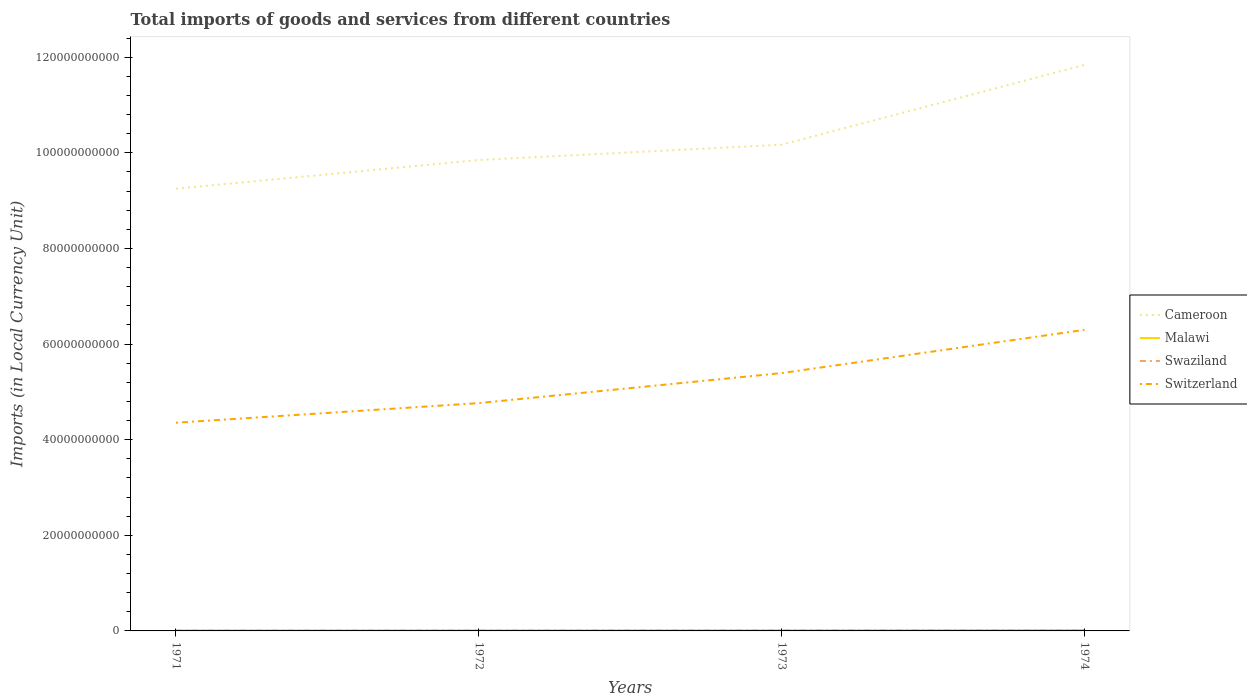Across all years, what is the maximum Amount of goods and services imports in Malawi?
Offer a very short reply. 1.08e+08. In which year was the Amount of goods and services imports in Malawi maximum?
Make the answer very short. 1971. What is the total Amount of goods and services imports in Malawi in the graph?
Keep it short and to the point. -4.30e+07. What is the difference between the highest and the second highest Amount of goods and services imports in Swaziland?
Make the answer very short. 5.28e+07. Is the Amount of goods and services imports in Swaziland strictly greater than the Amount of goods and services imports in Malawi over the years?
Offer a terse response. Yes. How many lines are there?
Offer a very short reply. 4. How many years are there in the graph?
Provide a succinct answer. 4. What is the difference between two consecutive major ticks on the Y-axis?
Offer a very short reply. 2.00e+1. Does the graph contain grids?
Provide a short and direct response. No. How many legend labels are there?
Keep it short and to the point. 4. What is the title of the graph?
Offer a terse response. Total imports of goods and services from different countries. What is the label or title of the Y-axis?
Your response must be concise. Imports (in Local Currency Unit). What is the Imports (in Local Currency Unit) in Cameroon in 1971?
Make the answer very short. 9.25e+1. What is the Imports (in Local Currency Unit) of Malawi in 1971?
Provide a short and direct response. 1.08e+08. What is the Imports (in Local Currency Unit) of Swaziland in 1971?
Provide a short and direct response. 5.36e+07. What is the Imports (in Local Currency Unit) of Switzerland in 1971?
Give a very brief answer. 4.35e+1. What is the Imports (in Local Currency Unit) in Cameroon in 1972?
Provide a short and direct response. 9.85e+1. What is the Imports (in Local Currency Unit) in Malawi in 1972?
Ensure brevity in your answer.  1.24e+08. What is the Imports (in Local Currency Unit) in Swaziland in 1972?
Make the answer very short. 6.61e+07. What is the Imports (in Local Currency Unit) of Switzerland in 1972?
Provide a succinct answer. 4.77e+1. What is the Imports (in Local Currency Unit) in Cameroon in 1973?
Ensure brevity in your answer.  1.02e+11. What is the Imports (in Local Currency Unit) of Malawi in 1973?
Your answer should be very brief. 1.37e+08. What is the Imports (in Local Currency Unit) in Swaziland in 1973?
Your answer should be very brief. 8.65e+07. What is the Imports (in Local Currency Unit) in Switzerland in 1973?
Offer a very short reply. 5.39e+1. What is the Imports (in Local Currency Unit) in Cameroon in 1974?
Offer a very short reply. 1.18e+11. What is the Imports (in Local Currency Unit) in Malawi in 1974?
Give a very brief answer. 1.80e+08. What is the Imports (in Local Currency Unit) of Swaziland in 1974?
Offer a very short reply. 1.06e+08. What is the Imports (in Local Currency Unit) of Switzerland in 1974?
Give a very brief answer. 6.30e+1. Across all years, what is the maximum Imports (in Local Currency Unit) of Cameroon?
Your answer should be very brief. 1.18e+11. Across all years, what is the maximum Imports (in Local Currency Unit) of Malawi?
Offer a terse response. 1.80e+08. Across all years, what is the maximum Imports (in Local Currency Unit) of Swaziland?
Your response must be concise. 1.06e+08. Across all years, what is the maximum Imports (in Local Currency Unit) in Switzerland?
Offer a terse response. 6.30e+1. Across all years, what is the minimum Imports (in Local Currency Unit) of Cameroon?
Make the answer very short. 9.25e+1. Across all years, what is the minimum Imports (in Local Currency Unit) in Malawi?
Make the answer very short. 1.08e+08. Across all years, what is the minimum Imports (in Local Currency Unit) of Swaziland?
Provide a short and direct response. 5.36e+07. Across all years, what is the minimum Imports (in Local Currency Unit) of Switzerland?
Your answer should be very brief. 4.35e+1. What is the total Imports (in Local Currency Unit) in Cameroon in the graph?
Your answer should be compact. 4.11e+11. What is the total Imports (in Local Currency Unit) in Malawi in the graph?
Keep it short and to the point. 5.48e+08. What is the total Imports (in Local Currency Unit) in Swaziland in the graph?
Your response must be concise. 3.13e+08. What is the total Imports (in Local Currency Unit) in Switzerland in the graph?
Your response must be concise. 2.08e+11. What is the difference between the Imports (in Local Currency Unit) in Cameroon in 1971 and that in 1972?
Offer a very short reply. -6.00e+09. What is the difference between the Imports (in Local Currency Unit) of Malawi in 1971 and that in 1972?
Provide a succinct answer. -1.58e+07. What is the difference between the Imports (in Local Currency Unit) in Swaziland in 1971 and that in 1972?
Provide a succinct answer. -1.25e+07. What is the difference between the Imports (in Local Currency Unit) of Switzerland in 1971 and that in 1972?
Your answer should be very brief. -4.10e+09. What is the difference between the Imports (in Local Currency Unit) of Cameroon in 1971 and that in 1973?
Offer a terse response. -9.20e+09. What is the difference between the Imports (in Local Currency Unit) of Malawi in 1971 and that in 1973?
Offer a very short reply. -2.91e+07. What is the difference between the Imports (in Local Currency Unit) of Swaziland in 1971 and that in 1973?
Provide a short and direct response. -3.29e+07. What is the difference between the Imports (in Local Currency Unit) in Switzerland in 1971 and that in 1973?
Offer a terse response. -1.04e+1. What is the difference between the Imports (in Local Currency Unit) in Cameroon in 1971 and that in 1974?
Keep it short and to the point. -2.59e+1. What is the difference between the Imports (in Local Currency Unit) of Malawi in 1971 and that in 1974?
Your response must be concise. -7.21e+07. What is the difference between the Imports (in Local Currency Unit) of Swaziland in 1971 and that in 1974?
Give a very brief answer. -5.28e+07. What is the difference between the Imports (in Local Currency Unit) of Switzerland in 1971 and that in 1974?
Keep it short and to the point. -1.94e+1. What is the difference between the Imports (in Local Currency Unit) in Cameroon in 1972 and that in 1973?
Provide a succinct answer. -3.20e+09. What is the difference between the Imports (in Local Currency Unit) of Malawi in 1972 and that in 1973?
Provide a succinct answer. -1.33e+07. What is the difference between the Imports (in Local Currency Unit) in Swaziland in 1972 and that in 1973?
Give a very brief answer. -2.04e+07. What is the difference between the Imports (in Local Currency Unit) of Switzerland in 1972 and that in 1973?
Provide a short and direct response. -6.28e+09. What is the difference between the Imports (in Local Currency Unit) in Cameroon in 1972 and that in 1974?
Keep it short and to the point. -1.99e+1. What is the difference between the Imports (in Local Currency Unit) of Malawi in 1972 and that in 1974?
Your response must be concise. -5.63e+07. What is the difference between the Imports (in Local Currency Unit) of Swaziland in 1972 and that in 1974?
Provide a succinct answer. -4.03e+07. What is the difference between the Imports (in Local Currency Unit) of Switzerland in 1972 and that in 1974?
Keep it short and to the point. -1.53e+1. What is the difference between the Imports (in Local Currency Unit) of Cameroon in 1973 and that in 1974?
Keep it short and to the point. -1.67e+1. What is the difference between the Imports (in Local Currency Unit) of Malawi in 1973 and that in 1974?
Offer a very short reply. -4.30e+07. What is the difference between the Imports (in Local Currency Unit) in Swaziland in 1973 and that in 1974?
Make the answer very short. -1.99e+07. What is the difference between the Imports (in Local Currency Unit) of Switzerland in 1973 and that in 1974?
Provide a succinct answer. -9.04e+09. What is the difference between the Imports (in Local Currency Unit) of Cameroon in 1971 and the Imports (in Local Currency Unit) of Malawi in 1972?
Ensure brevity in your answer.  9.24e+1. What is the difference between the Imports (in Local Currency Unit) in Cameroon in 1971 and the Imports (in Local Currency Unit) in Swaziland in 1972?
Keep it short and to the point. 9.24e+1. What is the difference between the Imports (in Local Currency Unit) of Cameroon in 1971 and the Imports (in Local Currency Unit) of Switzerland in 1972?
Provide a short and direct response. 4.48e+1. What is the difference between the Imports (in Local Currency Unit) of Malawi in 1971 and the Imports (in Local Currency Unit) of Swaziland in 1972?
Provide a short and direct response. 4.16e+07. What is the difference between the Imports (in Local Currency Unit) of Malawi in 1971 and the Imports (in Local Currency Unit) of Switzerland in 1972?
Keep it short and to the point. -4.75e+1. What is the difference between the Imports (in Local Currency Unit) in Swaziland in 1971 and the Imports (in Local Currency Unit) in Switzerland in 1972?
Provide a short and direct response. -4.76e+1. What is the difference between the Imports (in Local Currency Unit) of Cameroon in 1971 and the Imports (in Local Currency Unit) of Malawi in 1973?
Make the answer very short. 9.24e+1. What is the difference between the Imports (in Local Currency Unit) in Cameroon in 1971 and the Imports (in Local Currency Unit) in Swaziland in 1973?
Your answer should be very brief. 9.24e+1. What is the difference between the Imports (in Local Currency Unit) of Cameroon in 1971 and the Imports (in Local Currency Unit) of Switzerland in 1973?
Keep it short and to the point. 3.86e+1. What is the difference between the Imports (in Local Currency Unit) of Malawi in 1971 and the Imports (in Local Currency Unit) of Swaziland in 1973?
Ensure brevity in your answer.  2.12e+07. What is the difference between the Imports (in Local Currency Unit) of Malawi in 1971 and the Imports (in Local Currency Unit) of Switzerland in 1973?
Your answer should be very brief. -5.38e+1. What is the difference between the Imports (in Local Currency Unit) of Swaziland in 1971 and the Imports (in Local Currency Unit) of Switzerland in 1973?
Offer a very short reply. -5.39e+1. What is the difference between the Imports (in Local Currency Unit) in Cameroon in 1971 and the Imports (in Local Currency Unit) in Malawi in 1974?
Make the answer very short. 9.23e+1. What is the difference between the Imports (in Local Currency Unit) in Cameroon in 1971 and the Imports (in Local Currency Unit) in Swaziland in 1974?
Offer a terse response. 9.24e+1. What is the difference between the Imports (in Local Currency Unit) of Cameroon in 1971 and the Imports (in Local Currency Unit) of Switzerland in 1974?
Offer a very short reply. 2.95e+1. What is the difference between the Imports (in Local Currency Unit) of Malawi in 1971 and the Imports (in Local Currency Unit) of Swaziland in 1974?
Ensure brevity in your answer.  1.30e+06. What is the difference between the Imports (in Local Currency Unit) of Malawi in 1971 and the Imports (in Local Currency Unit) of Switzerland in 1974?
Give a very brief answer. -6.29e+1. What is the difference between the Imports (in Local Currency Unit) in Swaziland in 1971 and the Imports (in Local Currency Unit) in Switzerland in 1974?
Offer a very short reply. -6.29e+1. What is the difference between the Imports (in Local Currency Unit) in Cameroon in 1972 and the Imports (in Local Currency Unit) in Malawi in 1973?
Make the answer very short. 9.84e+1. What is the difference between the Imports (in Local Currency Unit) of Cameroon in 1972 and the Imports (in Local Currency Unit) of Swaziland in 1973?
Offer a terse response. 9.84e+1. What is the difference between the Imports (in Local Currency Unit) in Cameroon in 1972 and the Imports (in Local Currency Unit) in Switzerland in 1973?
Provide a short and direct response. 4.46e+1. What is the difference between the Imports (in Local Currency Unit) of Malawi in 1972 and the Imports (in Local Currency Unit) of Swaziland in 1973?
Your answer should be very brief. 3.70e+07. What is the difference between the Imports (in Local Currency Unit) in Malawi in 1972 and the Imports (in Local Currency Unit) in Switzerland in 1973?
Provide a short and direct response. -5.38e+1. What is the difference between the Imports (in Local Currency Unit) of Swaziland in 1972 and the Imports (in Local Currency Unit) of Switzerland in 1973?
Provide a succinct answer. -5.39e+1. What is the difference between the Imports (in Local Currency Unit) in Cameroon in 1972 and the Imports (in Local Currency Unit) in Malawi in 1974?
Your answer should be compact. 9.83e+1. What is the difference between the Imports (in Local Currency Unit) in Cameroon in 1972 and the Imports (in Local Currency Unit) in Swaziland in 1974?
Ensure brevity in your answer.  9.84e+1. What is the difference between the Imports (in Local Currency Unit) in Cameroon in 1972 and the Imports (in Local Currency Unit) in Switzerland in 1974?
Offer a very short reply. 3.55e+1. What is the difference between the Imports (in Local Currency Unit) in Malawi in 1972 and the Imports (in Local Currency Unit) in Swaziland in 1974?
Your answer should be compact. 1.71e+07. What is the difference between the Imports (in Local Currency Unit) of Malawi in 1972 and the Imports (in Local Currency Unit) of Switzerland in 1974?
Your response must be concise. -6.28e+1. What is the difference between the Imports (in Local Currency Unit) in Swaziland in 1972 and the Imports (in Local Currency Unit) in Switzerland in 1974?
Your answer should be very brief. -6.29e+1. What is the difference between the Imports (in Local Currency Unit) in Cameroon in 1973 and the Imports (in Local Currency Unit) in Malawi in 1974?
Provide a short and direct response. 1.02e+11. What is the difference between the Imports (in Local Currency Unit) of Cameroon in 1973 and the Imports (in Local Currency Unit) of Swaziland in 1974?
Your answer should be very brief. 1.02e+11. What is the difference between the Imports (in Local Currency Unit) in Cameroon in 1973 and the Imports (in Local Currency Unit) in Switzerland in 1974?
Offer a terse response. 3.87e+1. What is the difference between the Imports (in Local Currency Unit) of Malawi in 1973 and the Imports (in Local Currency Unit) of Swaziland in 1974?
Offer a terse response. 3.04e+07. What is the difference between the Imports (in Local Currency Unit) in Malawi in 1973 and the Imports (in Local Currency Unit) in Switzerland in 1974?
Your answer should be very brief. -6.28e+1. What is the difference between the Imports (in Local Currency Unit) of Swaziland in 1973 and the Imports (in Local Currency Unit) of Switzerland in 1974?
Your response must be concise. -6.29e+1. What is the average Imports (in Local Currency Unit) of Cameroon per year?
Your answer should be compact. 1.03e+11. What is the average Imports (in Local Currency Unit) in Malawi per year?
Make the answer very short. 1.37e+08. What is the average Imports (in Local Currency Unit) of Swaziland per year?
Offer a terse response. 7.82e+07. What is the average Imports (in Local Currency Unit) of Switzerland per year?
Make the answer very short. 5.20e+1. In the year 1971, what is the difference between the Imports (in Local Currency Unit) of Cameroon and Imports (in Local Currency Unit) of Malawi?
Your answer should be very brief. 9.24e+1. In the year 1971, what is the difference between the Imports (in Local Currency Unit) of Cameroon and Imports (in Local Currency Unit) of Swaziland?
Offer a terse response. 9.24e+1. In the year 1971, what is the difference between the Imports (in Local Currency Unit) of Cameroon and Imports (in Local Currency Unit) of Switzerland?
Your answer should be compact. 4.90e+1. In the year 1971, what is the difference between the Imports (in Local Currency Unit) in Malawi and Imports (in Local Currency Unit) in Swaziland?
Offer a very short reply. 5.41e+07. In the year 1971, what is the difference between the Imports (in Local Currency Unit) in Malawi and Imports (in Local Currency Unit) in Switzerland?
Offer a terse response. -4.34e+1. In the year 1971, what is the difference between the Imports (in Local Currency Unit) in Swaziland and Imports (in Local Currency Unit) in Switzerland?
Offer a very short reply. -4.35e+1. In the year 1972, what is the difference between the Imports (in Local Currency Unit) of Cameroon and Imports (in Local Currency Unit) of Malawi?
Provide a short and direct response. 9.84e+1. In the year 1972, what is the difference between the Imports (in Local Currency Unit) of Cameroon and Imports (in Local Currency Unit) of Swaziland?
Provide a short and direct response. 9.84e+1. In the year 1972, what is the difference between the Imports (in Local Currency Unit) in Cameroon and Imports (in Local Currency Unit) in Switzerland?
Keep it short and to the point. 5.08e+1. In the year 1972, what is the difference between the Imports (in Local Currency Unit) of Malawi and Imports (in Local Currency Unit) of Swaziland?
Provide a short and direct response. 5.74e+07. In the year 1972, what is the difference between the Imports (in Local Currency Unit) of Malawi and Imports (in Local Currency Unit) of Switzerland?
Your response must be concise. -4.75e+1. In the year 1972, what is the difference between the Imports (in Local Currency Unit) of Swaziland and Imports (in Local Currency Unit) of Switzerland?
Offer a terse response. -4.76e+1. In the year 1973, what is the difference between the Imports (in Local Currency Unit) in Cameroon and Imports (in Local Currency Unit) in Malawi?
Offer a terse response. 1.02e+11. In the year 1973, what is the difference between the Imports (in Local Currency Unit) of Cameroon and Imports (in Local Currency Unit) of Swaziland?
Provide a succinct answer. 1.02e+11. In the year 1973, what is the difference between the Imports (in Local Currency Unit) in Cameroon and Imports (in Local Currency Unit) in Switzerland?
Your answer should be compact. 4.78e+1. In the year 1973, what is the difference between the Imports (in Local Currency Unit) of Malawi and Imports (in Local Currency Unit) of Swaziland?
Keep it short and to the point. 5.03e+07. In the year 1973, what is the difference between the Imports (in Local Currency Unit) of Malawi and Imports (in Local Currency Unit) of Switzerland?
Your answer should be very brief. -5.38e+1. In the year 1973, what is the difference between the Imports (in Local Currency Unit) of Swaziland and Imports (in Local Currency Unit) of Switzerland?
Your answer should be very brief. -5.38e+1. In the year 1974, what is the difference between the Imports (in Local Currency Unit) of Cameroon and Imports (in Local Currency Unit) of Malawi?
Offer a very short reply. 1.18e+11. In the year 1974, what is the difference between the Imports (in Local Currency Unit) in Cameroon and Imports (in Local Currency Unit) in Swaziland?
Make the answer very short. 1.18e+11. In the year 1974, what is the difference between the Imports (in Local Currency Unit) in Cameroon and Imports (in Local Currency Unit) in Switzerland?
Offer a terse response. 5.54e+1. In the year 1974, what is the difference between the Imports (in Local Currency Unit) in Malawi and Imports (in Local Currency Unit) in Swaziland?
Offer a very short reply. 7.34e+07. In the year 1974, what is the difference between the Imports (in Local Currency Unit) in Malawi and Imports (in Local Currency Unit) in Switzerland?
Make the answer very short. -6.28e+1. In the year 1974, what is the difference between the Imports (in Local Currency Unit) of Swaziland and Imports (in Local Currency Unit) of Switzerland?
Offer a terse response. -6.29e+1. What is the ratio of the Imports (in Local Currency Unit) of Cameroon in 1971 to that in 1972?
Your answer should be compact. 0.94. What is the ratio of the Imports (in Local Currency Unit) in Malawi in 1971 to that in 1972?
Provide a succinct answer. 0.87. What is the ratio of the Imports (in Local Currency Unit) of Swaziland in 1971 to that in 1972?
Keep it short and to the point. 0.81. What is the ratio of the Imports (in Local Currency Unit) of Switzerland in 1971 to that in 1972?
Make the answer very short. 0.91. What is the ratio of the Imports (in Local Currency Unit) of Cameroon in 1971 to that in 1973?
Your answer should be compact. 0.91. What is the ratio of the Imports (in Local Currency Unit) of Malawi in 1971 to that in 1973?
Make the answer very short. 0.79. What is the ratio of the Imports (in Local Currency Unit) of Swaziland in 1971 to that in 1973?
Keep it short and to the point. 0.62. What is the ratio of the Imports (in Local Currency Unit) of Switzerland in 1971 to that in 1973?
Ensure brevity in your answer.  0.81. What is the ratio of the Imports (in Local Currency Unit) in Cameroon in 1971 to that in 1974?
Your answer should be very brief. 0.78. What is the ratio of the Imports (in Local Currency Unit) of Malawi in 1971 to that in 1974?
Your answer should be very brief. 0.6. What is the ratio of the Imports (in Local Currency Unit) in Swaziland in 1971 to that in 1974?
Your answer should be very brief. 0.5. What is the ratio of the Imports (in Local Currency Unit) of Switzerland in 1971 to that in 1974?
Offer a very short reply. 0.69. What is the ratio of the Imports (in Local Currency Unit) in Cameroon in 1972 to that in 1973?
Offer a terse response. 0.97. What is the ratio of the Imports (in Local Currency Unit) in Malawi in 1972 to that in 1973?
Your answer should be very brief. 0.9. What is the ratio of the Imports (in Local Currency Unit) in Swaziland in 1972 to that in 1973?
Offer a very short reply. 0.76. What is the ratio of the Imports (in Local Currency Unit) in Switzerland in 1972 to that in 1973?
Make the answer very short. 0.88. What is the ratio of the Imports (in Local Currency Unit) of Cameroon in 1972 to that in 1974?
Provide a succinct answer. 0.83. What is the ratio of the Imports (in Local Currency Unit) in Malawi in 1972 to that in 1974?
Offer a very short reply. 0.69. What is the ratio of the Imports (in Local Currency Unit) of Swaziland in 1972 to that in 1974?
Give a very brief answer. 0.62. What is the ratio of the Imports (in Local Currency Unit) in Switzerland in 1972 to that in 1974?
Keep it short and to the point. 0.76. What is the ratio of the Imports (in Local Currency Unit) in Cameroon in 1973 to that in 1974?
Provide a short and direct response. 0.86. What is the ratio of the Imports (in Local Currency Unit) of Malawi in 1973 to that in 1974?
Offer a terse response. 0.76. What is the ratio of the Imports (in Local Currency Unit) of Swaziland in 1973 to that in 1974?
Your answer should be compact. 0.81. What is the ratio of the Imports (in Local Currency Unit) of Switzerland in 1973 to that in 1974?
Your answer should be compact. 0.86. What is the difference between the highest and the second highest Imports (in Local Currency Unit) in Cameroon?
Provide a short and direct response. 1.67e+1. What is the difference between the highest and the second highest Imports (in Local Currency Unit) in Malawi?
Your response must be concise. 4.30e+07. What is the difference between the highest and the second highest Imports (in Local Currency Unit) in Swaziland?
Keep it short and to the point. 1.99e+07. What is the difference between the highest and the second highest Imports (in Local Currency Unit) of Switzerland?
Your response must be concise. 9.04e+09. What is the difference between the highest and the lowest Imports (in Local Currency Unit) in Cameroon?
Your response must be concise. 2.59e+1. What is the difference between the highest and the lowest Imports (in Local Currency Unit) of Malawi?
Offer a very short reply. 7.21e+07. What is the difference between the highest and the lowest Imports (in Local Currency Unit) in Swaziland?
Your answer should be compact. 5.28e+07. What is the difference between the highest and the lowest Imports (in Local Currency Unit) of Switzerland?
Your answer should be compact. 1.94e+1. 